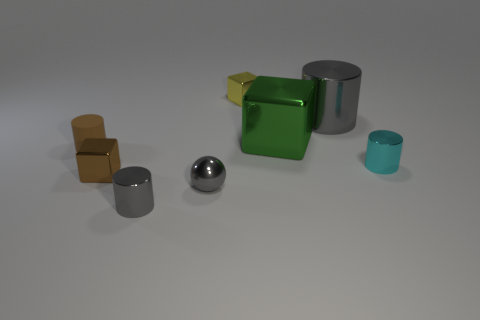Subtract all tiny yellow metal cubes. How many cubes are left? 2 Add 1 yellow metal things. How many objects exist? 9 Subtract all red cylinders. Subtract all blue blocks. How many cylinders are left? 4 Subtract all cubes. How many objects are left? 5 Subtract 1 gray balls. How many objects are left? 7 Subtract all cyan metallic things. Subtract all large green objects. How many objects are left? 6 Add 7 tiny gray cylinders. How many tiny gray cylinders are left? 8 Add 4 tiny brown cylinders. How many tiny brown cylinders exist? 5 